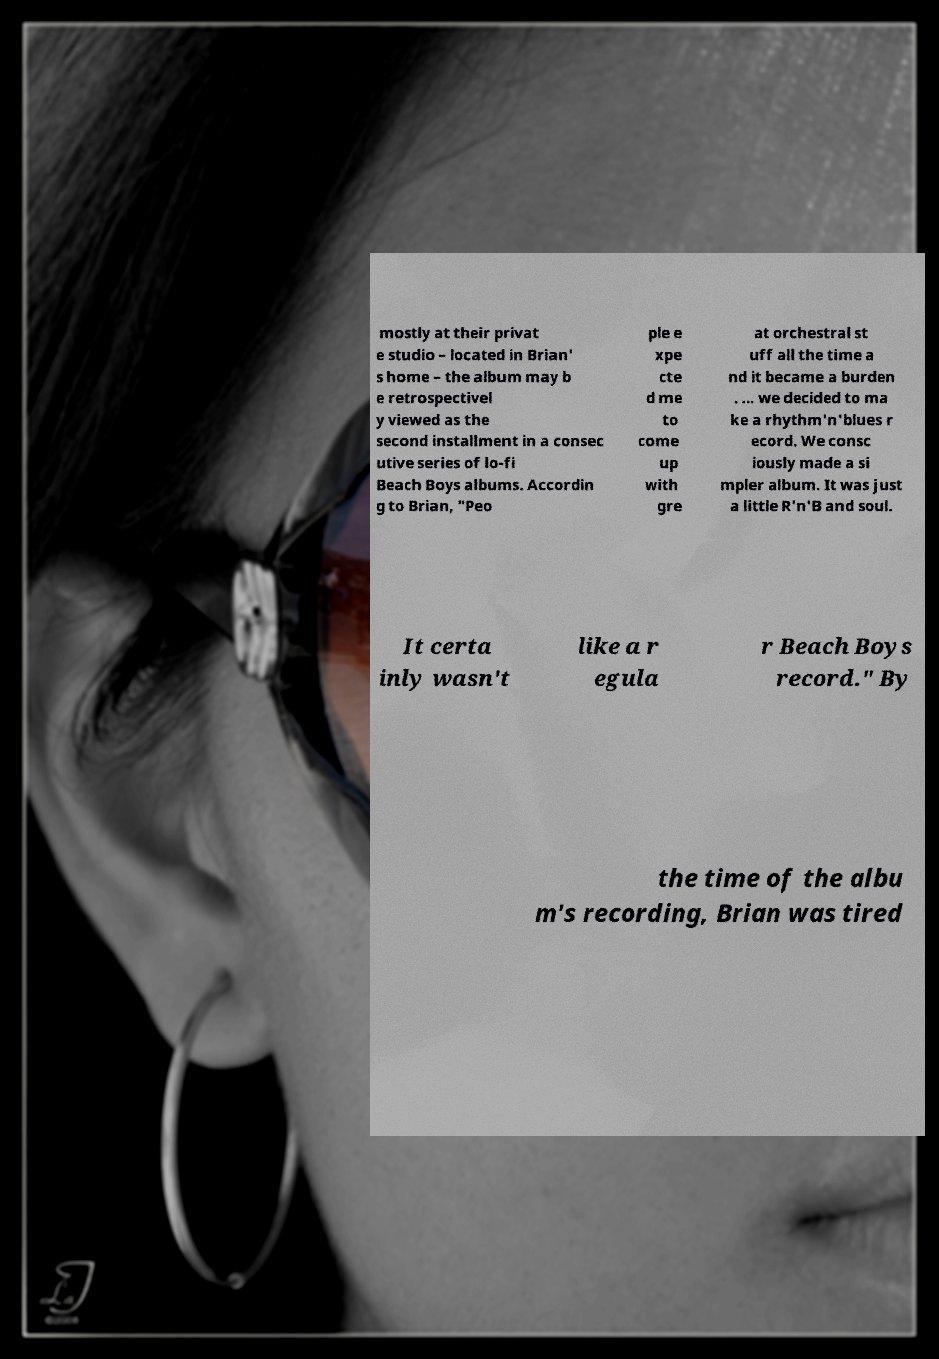I need the written content from this picture converted into text. Can you do that? mostly at their privat e studio – located in Brian' s home – the album may b e retrospectivel y viewed as the second installment in a consec utive series of lo-fi Beach Boys albums. Accordin g to Brian, "Peo ple e xpe cte d me to come up with gre at orchestral st uff all the time a nd it became a burden . ... we decided to ma ke a rhythm'n'blues r ecord. We consc iously made a si mpler album. It was just a little R'n'B and soul. It certa inly wasn't like a r egula r Beach Boys record." By the time of the albu m's recording, Brian was tired 